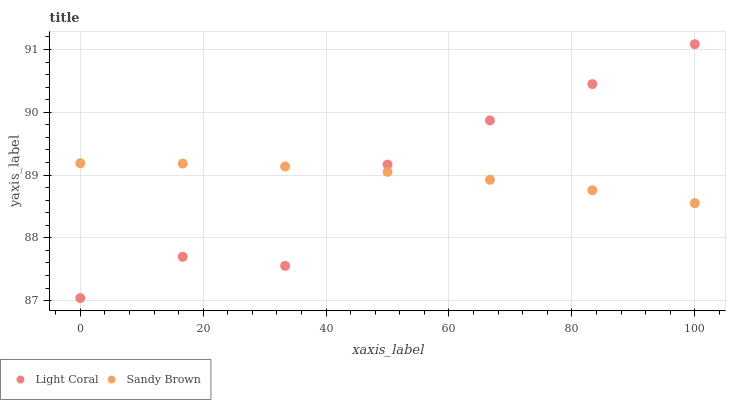Does Light Coral have the minimum area under the curve?
Answer yes or no. Yes. Does Sandy Brown have the maximum area under the curve?
Answer yes or no. Yes. Does Sandy Brown have the minimum area under the curve?
Answer yes or no. No. Is Sandy Brown the smoothest?
Answer yes or no. Yes. Is Light Coral the roughest?
Answer yes or no. Yes. Is Sandy Brown the roughest?
Answer yes or no. No. Does Light Coral have the lowest value?
Answer yes or no. Yes. Does Sandy Brown have the lowest value?
Answer yes or no. No. Does Light Coral have the highest value?
Answer yes or no. Yes. Does Sandy Brown have the highest value?
Answer yes or no. No. Does Sandy Brown intersect Light Coral?
Answer yes or no. Yes. Is Sandy Brown less than Light Coral?
Answer yes or no. No. Is Sandy Brown greater than Light Coral?
Answer yes or no. No. 